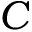Convert formula to latex. <formula><loc_0><loc_0><loc_500><loc_500>C</formula> 